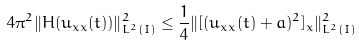Convert formula to latex. <formula><loc_0><loc_0><loc_500><loc_500>4 \pi ^ { 2 } \| H ( u _ { x x } ( t ) ) \| ^ { 2 } _ { L ^ { 2 } ( I ) } \leq \frac { 1 } { 4 } \| [ ( u _ { x x } ( t ) + a ) ^ { 2 } ] _ { x } \| ^ { 2 } _ { L ^ { 2 } ( I ) }</formula> 